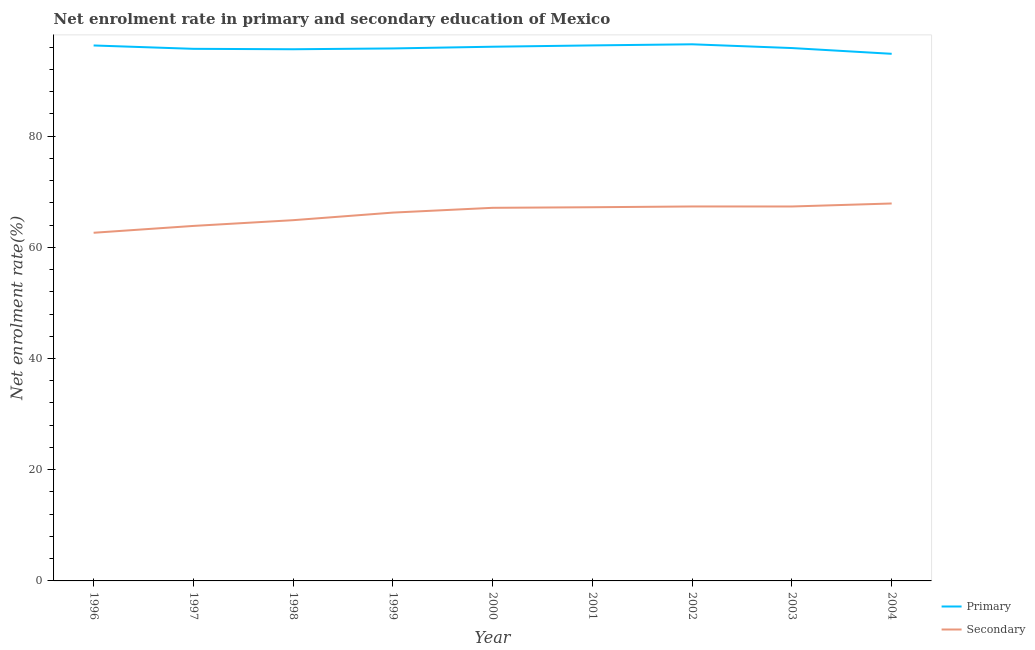How many different coloured lines are there?
Your answer should be compact. 2. Does the line corresponding to enrollment rate in primary education intersect with the line corresponding to enrollment rate in secondary education?
Ensure brevity in your answer.  No. Is the number of lines equal to the number of legend labels?
Provide a short and direct response. Yes. What is the enrollment rate in primary education in 1999?
Your response must be concise. 95.76. Across all years, what is the maximum enrollment rate in primary education?
Your response must be concise. 96.51. Across all years, what is the minimum enrollment rate in primary education?
Your answer should be very brief. 94.8. In which year was the enrollment rate in primary education maximum?
Make the answer very short. 2002. In which year was the enrollment rate in secondary education minimum?
Provide a succinct answer. 1996. What is the total enrollment rate in secondary education in the graph?
Your answer should be very brief. 594.43. What is the difference between the enrollment rate in primary education in 1997 and that in 2003?
Offer a terse response. -0.14. What is the difference between the enrollment rate in primary education in 1999 and the enrollment rate in secondary education in 2000?
Keep it short and to the point. 28.66. What is the average enrollment rate in primary education per year?
Provide a succinct answer. 95.87. In the year 1999, what is the difference between the enrollment rate in secondary education and enrollment rate in primary education?
Give a very brief answer. -29.52. In how many years, is the enrollment rate in secondary education greater than 56 %?
Provide a succinct answer. 9. What is the ratio of the enrollment rate in secondary education in 1997 to that in 2002?
Offer a terse response. 0.95. Is the enrollment rate in secondary education in 2003 less than that in 2004?
Provide a short and direct response. Yes. Is the difference between the enrollment rate in primary education in 1996 and 1999 greater than the difference between the enrollment rate in secondary education in 1996 and 1999?
Offer a very short reply. Yes. What is the difference between the highest and the second highest enrollment rate in primary education?
Make the answer very short. 0.2. What is the difference between the highest and the lowest enrollment rate in secondary education?
Give a very brief answer. 5.26. Is the enrollment rate in secondary education strictly greater than the enrollment rate in primary education over the years?
Provide a short and direct response. No. Is the enrollment rate in primary education strictly less than the enrollment rate in secondary education over the years?
Provide a short and direct response. No. How many years are there in the graph?
Offer a very short reply. 9. What is the difference between two consecutive major ticks on the Y-axis?
Provide a succinct answer. 20. Are the values on the major ticks of Y-axis written in scientific E-notation?
Make the answer very short. No. Where does the legend appear in the graph?
Your response must be concise. Bottom right. How are the legend labels stacked?
Provide a succinct answer. Vertical. What is the title of the graph?
Give a very brief answer. Net enrolment rate in primary and secondary education of Mexico. Does "Female entrants" appear as one of the legend labels in the graph?
Provide a short and direct response. No. What is the label or title of the X-axis?
Give a very brief answer. Year. What is the label or title of the Y-axis?
Provide a short and direct response. Net enrolment rate(%). What is the Net enrolment rate(%) of Primary in 1996?
Provide a short and direct response. 96.3. What is the Net enrolment rate(%) in Secondary in 1996?
Your answer should be compact. 62.61. What is the Net enrolment rate(%) of Primary in 1997?
Offer a very short reply. 95.69. What is the Net enrolment rate(%) in Secondary in 1997?
Ensure brevity in your answer.  63.84. What is the Net enrolment rate(%) of Primary in 1998?
Make the answer very short. 95.62. What is the Net enrolment rate(%) in Secondary in 1998?
Provide a succinct answer. 64.88. What is the Net enrolment rate(%) in Primary in 1999?
Provide a succinct answer. 95.76. What is the Net enrolment rate(%) in Secondary in 1999?
Your answer should be compact. 66.24. What is the Net enrolment rate(%) of Primary in 2000?
Give a very brief answer. 96.07. What is the Net enrolment rate(%) in Secondary in 2000?
Keep it short and to the point. 67.1. What is the Net enrolment rate(%) in Primary in 2001?
Your response must be concise. 96.31. What is the Net enrolment rate(%) in Secondary in 2001?
Keep it short and to the point. 67.2. What is the Net enrolment rate(%) in Primary in 2002?
Provide a succinct answer. 96.51. What is the Net enrolment rate(%) of Secondary in 2002?
Your answer should be very brief. 67.34. What is the Net enrolment rate(%) of Primary in 2003?
Ensure brevity in your answer.  95.83. What is the Net enrolment rate(%) of Secondary in 2003?
Offer a very short reply. 67.34. What is the Net enrolment rate(%) of Primary in 2004?
Provide a short and direct response. 94.8. What is the Net enrolment rate(%) in Secondary in 2004?
Provide a succinct answer. 67.88. Across all years, what is the maximum Net enrolment rate(%) of Primary?
Your response must be concise. 96.51. Across all years, what is the maximum Net enrolment rate(%) of Secondary?
Give a very brief answer. 67.88. Across all years, what is the minimum Net enrolment rate(%) of Primary?
Keep it short and to the point. 94.8. Across all years, what is the minimum Net enrolment rate(%) in Secondary?
Your answer should be compact. 62.61. What is the total Net enrolment rate(%) in Primary in the graph?
Offer a very short reply. 862.87. What is the total Net enrolment rate(%) in Secondary in the graph?
Provide a succinct answer. 594.43. What is the difference between the Net enrolment rate(%) of Primary in 1996 and that in 1997?
Offer a terse response. 0.6. What is the difference between the Net enrolment rate(%) of Secondary in 1996 and that in 1997?
Provide a short and direct response. -1.23. What is the difference between the Net enrolment rate(%) in Primary in 1996 and that in 1998?
Provide a short and direct response. 0.68. What is the difference between the Net enrolment rate(%) in Secondary in 1996 and that in 1998?
Your response must be concise. -2.26. What is the difference between the Net enrolment rate(%) of Primary in 1996 and that in 1999?
Your response must be concise. 0.53. What is the difference between the Net enrolment rate(%) of Secondary in 1996 and that in 1999?
Your response must be concise. -3.63. What is the difference between the Net enrolment rate(%) of Primary in 1996 and that in 2000?
Provide a short and direct response. 0.23. What is the difference between the Net enrolment rate(%) of Secondary in 1996 and that in 2000?
Make the answer very short. -4.49. What is the difference between the Net enrolment rate(%) in Primary in 1996 and that in 2001?
Give a very brief answer. -0.01. What is the difference between the Net enrolment rate(%) in Secondary in 1996 and that in 2001?
Your answer should be very brief. -4.59. What is the difference between the Net enrolment rate(%) in Primary in 1996 and that in 2002?
Provide a short and direct response. -0.21. What is the difference between the Net enrolment rate(%) in Secondary in 1996 and that in 2002?
Your answer should be very brief. -4.73. What is the difference between the Net enrolment rate(%) in Primary in 1996 and that in 2003?
Provide a short and direct response. 0.46. What is the difference between the Net enrolment rate(%) of Secondary in 1996 and that in 2003?
Your answer should be very brief. -4.73. What is the difference between the Net enrolment rate(%) in Primary in 1996 and that in 2004?
Offer a very short reply. 1.5. What is the difference between the Net enrolment rate(%) in Secondary in 1996 and that in 2004?
Make the answer very short. -5.26. What is the difference between the Net enrolment rate(%) of Primary in 1997 and that in 1998?
Your answer should be compact. 0.08. What is the difference between the Net enrolment rate(%) in Secondary in 1997 and that in 1998?
Offer a terse response. -1.03. What is the difference between the Net enrolment rate(%) of Primary in 1997 and that in 1999?
Provide a short and direct response. -0.07. What is the difference between the Net enrolment rate(%) in Secondary in 1997 and that in 1999?
Offer a very short reply. -2.4. What is the difference between the Net enrolment rate(%) of Primary in 1997 and that in 2000?
Your answer should be compact. -0.38. What is the difference between the Net enrolment rate(%) in Secondary in 1997 and that in 2000?
Your answer should be very brief. -3.26. What is the difference between the Net enrolment rate(%) of Primary in 1997 and that in 2001?
Your answer should be compact. -0.62. What is the difference between the Net enrolment rate(%) of Secondary in 1997 and that in 2001?
Offer a very short reply. -3.36. What is the difference between the Net enrolment rate(%) of Primary in 1997 and that in 2002?
Your answer should be very brief. -0.81. What is the difference between the Net enrolment rate(%) of Secondary in 1997 and that in 2002?
Make the answer very short. -3.5. What is the difference between the Net enrolment rate(%) of Primary in 1997 and that in 2003?
Give a very brief answer. -0.14. What is the difference between the Net enrolment rate(%) in Secondary in 1997 and that in 2003?
Your answer should be very brief. -3.5. What is the difference between the Net enrolment rate(%) of Primary in 1997 and that in 2004?
Provide a succinct answer. 0.9. What is the difference between the Net enrolment rate(%) in Secondary in 1997 and that in 2004?
Keep it short and to the point. -4.04. What is the difference between the Net enrolment rate(%) of Primary in 1998 and that in 1999?
Make the answer very short. -0.15. What is the difference between the Net enrolment rate(%) of Secondary in 1998 and that in 1999?
Make the answer very short. -1.36. What is the difference between the Net enrolment rate(%) of Primary in 1998 and that in 2000?
Ensure brevity in your answer.  -0.45. What is the difference between the Net enrolment rate(%) of Secondary in 1998 and that in 2000?
Your answer should be compact. -2.22. What is the difference between the Net enrolment rate(%) in Primary in 1998 and that in 2001?
Give a very brief answer. -0.69. What is the difference between the Net enrolment rate(%) in Secondary in 1998 and that in 2001?
Your answer should be very brief. -2.33. What is the difference between the Net enrolment rate(%) of Primary in 1998 and that in 2002?
Your answer should be very brief. -0.89. What is the difference between the Net enrolment rate(%) in Secondary in 1998 and that in 2002?
Keep it short and to the point. -2.47. What is the difference between the Net enrolment rate(%) of Primary in 1998 and that in 2003?
Ensure brevity in your answer.  -0.21. What is the difference between the Net enrolment rate(%) in Secondary in 1998 and that in 2003?
Ensure brevity in your answer.  -2.46. What is the difference between the Net enrolment rate(%) in Primary in 1998 and that in 2004?
Provide a succinct answer. 0.82. What is the difference between the Net enrolment rate(%) of Secondary in 1998 and that in 2004?
Your answer should be compact. -3. What is the difference between the Net enrolment rate(%) of Primary in 1999 and that in 2000?
Your response must be concise. -0.31. What is the difference between the Net enrolment rate(%) of Secondary in 1999 and that in 2000?
Your answer should be very brief. -0.86. What is the difference between the Net enrolment rate(%) in Primary in 1999 and that in 2001?
Give a very brief answer. -0.55. What is the difference between the Net enrolment rate(%) of Secondary in 1999 and that in 2001?
Ensure brevity in your answer.  -0.96. What is the difference between the Net enrolment rate(%) in Primary in 1999 and that in 2002?
Your response must be concise. -0.74. What is the difference between the Net enrolment rate(%) of Secondary in 1999 and that in 2002?
Offer a very short reply. -1.1. What is the difference between the Net enrolment rate(%) in Primary in 1999 and that in 2003?
Offer a terse response. -0.07. What is the difference between the Net enrolment rate(%) in Secondary in 1999 and that in 2003?
Keep it short and to the point. -1.1. What is the difference between the Net enrolment rate(%) of Secondary in 1999 and that in 2004?
Provide a short and direct response. -1.64. What is the difference between the Net enrolment rate(%) of Primary in 2000 and that in 2001?
Offer a terse response. -0.24. What is the difference between the Net enrolment rate(%) of Secondary in 2000 and that in 2001?
Provide a succinct answer. -0.1. What is the difference between the Net enrolment rate(%) of Primary in 2000 and that in 2002?
Provide a succinct answer. -0.44. What is the difference between the Net enrolment rate(%) of Secondary in 2000 and that in 2002?
Ensure brevity in your answer.  -0.24. What is the difference between the Net enrolment rate(%) in Primary in 2000 and that in 2003?
Provide a succinct answer. 0.24. What is the difference between the Net enrolment rate(%) of Secondary in 2000 and that in 2003?
Keep it short and to the point. -0.24. What is the difference between the Net enrolment rate(%) of Primary in 2000 and that in 2004?
Keep it short and to the point. 1.27. What is the difference between the Net enrolment rate(%) in Secondary in 2000 and that in 2004?
Provide a short and direct response. -0.78. What is the difference between the Net enrolment rate(%) in Primary in 2001 and that in 2002?
Provide a succinct answer. -0.2. What is the difference between the Net enrolment rate(%) in Secondary in 2001 and that in 2002?
Offer a very short reply. -0.14. What is the difference between the Net enrolment rate(%) of Primary in 2001 and that in 2003?
Give a very brief answer. 0.48. What is the difference between the Net enrolment rate(%) in Secondary in 2001 and that in 2003?
Your answer should be compact. -0.14. What is the difference between the Net enrolment rate(%) in Primary in 2001 and that in 2004?
Provide a succinct answer. 1.51. What is the difference between the Net enrolment rate(%) of Secondary in 2001 and that in 2004?
Ensure brevity in your answer.  -0.67. What is the difference between the Net enrolment rate(%) in Primary in 2002 and that in 2003?
Your answer should be very brief. 0.68. What is the difference between the Net enrolment rate(%) of Secondary in 2002 and that in 2003?
Make the answer very short. 0. What is the difference between the Net enrolment rate(%) of Primary in 2002 and that in 2004?
Keep it short and to the point. 1.71. What is the difference between the Net enrolment rate(%) of Secondary in 2002 and that in 2004?
Provide a short and direct response. -0.54. What is the difference between the Net enrolment rate(%) of Primary in 2003 and that in 2004?
Provide a succinct answer. 1.03. What is the difference between the Net enrolment rate(%) in Secondary in 2003 and that in 2004?
Provide a succinct answer. -0.54. What is the difference between the Net enrolment rate(%) in Primary in 1996 and the Net enrolment rate(%) in Secondary in 1997?
Make the answer very short. 32.45. What is the difference between the Net enrolment rate(%) of Primary in 1996 and the Net enrolment rate(%) of Secondary in 1998?
Offer a terse response. 31.42. What is the difference between the Net enrolment rate(%) of Primary in 1996 and the Net enrolment rate(%) of Secondary in 1999?
Offer a terse response. 30.06. What is the difference between the Net enrolment rate(%) of Primary in 1996 and the Net enrolment rate(%) of Secondary in 2000?
Your response must be concise. 29.2. What is the difference between the Net enrolment rate(%) of Primary in 1996 and the Net enrolment rate(%) of Secondary in 2001?
Your response must be concise. 29.09. What is the difference between the Net enrolment rate(%) of Primary in 1996 and the Net enrolment rate(%) of Secondary in 2002?
Your answer should be very brief. 28.95. What is the difference between the Net enrolment rate(%) of Primary in 1996 and the Net enrolment rate(%) of Secondary in 2003?
Provide a succinct answer. 28.96. What is the difference between the Net enrolment rate(%) in Primary in 1996 and the Net enrolment rate(%) in Secondary in 2004?
Your answer should be very brief. 28.42. What is the difference between the Net enrolment rate(%) in Primary in 1997 and the Net enrolment rate(%) in Secondary in 1998?
Provide a succinct answer. 30.82. What is the difference between the Net enrolment rate(%) of Primary in 1997 and the Net enrolment rate(%) of Secondary in 1999?
Offer a terse response. 29.45. What is the difference between the Net enrolment rate(%) in Primary in 1997 and the Net enrolment rate(%) in Secondary in 2000?
Your answer should be very brief. 28.59. What is the difference between the Net enrolment rate(%) in Primary in 1997 and the Net enrolment rate(%) in Secondary in 2001?
Your response must be concise. 28.49. What is the difference between the Net enrolment rate(%) in Primary in 1997 and the Net enrolment rate(%) in Secondary in 2002?
Your answer should be very brief. 28.35. What is the difference between the Net enrolment rate(%) in Primary in 1997 and the Net enrolment rate(%) in Secondary in 2003?
Keep it short and to the point. 28.35. What is the difference between the Net enrolment rate(%) in Primary in 1997 and the Net enrolment rate(%) in Secondary in 2004?
Your answer should be very brief. 27.82. What is the difference between the Net enrolment rate(%) of Primary in 1998 and the Net enrolment rate(%) of Secondary in 1999?
Make the answer very short. 29.38. What is the difference between the Net enrolment rate(%) of Primary in 1998 and the Net enrolment rate(%) of Secondary in 2000?
Your answer should be compact. 28.52. What is the difference between the Net enrolment rate(%) of Primary in 1998 and the Net enrolment rate(%) of Secondary in 2001?
Offer a terse response. 28.41. What is the difference between the Net enrolment rate(%) in Primary in 1998 and the Net enrolment rate(%) in Secondary in 2002?
Your response must be concise. 28.27. What is the difference between the Net enrolment rate(%) of Primary in 1998 and the Net enrolment rate(%) of Secondary in 2003?
Give a very brief answer. 28.28. What is the difference between the Net enrolment rate(%) of Primary in 1998 and the Net enrolment rate(%) of Secondary in 2004?
Provide a succinct answer. 27.74. What is the difference between the Net enrolment rate(%) in Primary in 1999 and the Net enrolment rate(%) in Secondary in 2000?
Your response must be concise. 28.66. What is the difference between the Net enrolment rate(%) in Primary in 1999 and the Net enrolment rate(%) in Secondary in 2001?
Your answer should be compact. 28.56. What is the difference between the Net enrolment rate(%) of Primary in 1999 and the Net enrolment rate(%) of Secondary in 2002?
Your answer should be very brief. 28.42. What is the difference between the Net enrolment rate(%) of Primary in 1999 and the Net enrolment rate(%) of Secondary in 2003?
Provide a succinct answer. 28.42. What is the difference between the Net enrolment rate(%) in Primary in 1999 and the Net enrolment rate(%) in Secondary in 2004?
Keep it short and to the point. 27.89. What is the difference between the Net enrolment rate(%) of Primary in 2000 and the Net enrolment rate(%) of Secondary in 2001?
Your answer should be very brief. 28.87. What is the difference between the Net enrolment rate(%) in Primary in 2000 and the Net enrolment rate(%) in Secondary in 2002?
Provide a succinct answer. 28.73. What is the difference between the Net enrolment rate(%) of Primary in 2000 and the Net enrolment rate(%) of Secondary in 2003?
Offer a very short reply. 28.73. What is the difference between the Net enrolment rate(%) of Primary in 2000 and the Net enrolment rate(%) of Secondary in 2004?
Give a very brief answer. 28.19. What is the difference between the Net enrolment rate(%) in Primary in 2001 and the Net enrolment rate(%) in Secondary in 2002?
Offer a very short reply. 28.97. What is the difference between the Net enrolment rate(%) of Primary in 2001 and the Net enrolment rate(%) of Secondary in 2003?
Make the answer very short. 28.97. What is the difference between the Net enrolment rate(%) of Primary in 2001 and the Net enrolment rate(%) of Secondary in 2004?
Offer a very short reply. 28.43. What is the difference between the Net enrolment rate(%) of Primary in 2002 and the Net enrolment rate(%) of Secondary in 2003?
Ensure brevity in your answer.  29.17. What is the difference between the Net enrolment rate(%) in Primary in 2002 and the Net enrolment rate(%) in Secondary in 2004?
Offer a terse response. 28.63. What is the difference between the Net enrolment rate(%) of Primary in 2003 and the Net enrolment rate(%) of Secondary in 2004?
Ensure brevity in your answer.  27.95. What is the average Net enrolment rate(%) of Primary per year?
Give a very brief answer. 95.88. What is the average Net enrolment rate(%) in Secondary per year?
Offer a very short reply. 66.05. In the year 1996, what is the difference between the Net enrolment rate(%) of Primary and Net enrolment rate(%) of Secondary?
Provide a succinct answer. 33.68. In the year 1997, what is the difference between the Net enrolment rate(%) of Primary and Net enrolment rate(%) of Secondary?
Your answer should be compact. 31.85. In the year 1998, what is the difference between the Net enrolment rate(%) in Primary and Net enrolment rate(%) in Secondary?
Your answer should be very brief. 30.74. In the year 1999, what is the difference between the Net enrolment rate(%) of Primary and Net enrolment rate(%) of Secondary?
Your answer should be compact. 29.52. In the year 2000, what is the difference between the Net enrolment rate(%) in Primary and Net enrolment rate(%) in Secondary?
Offer a very short reply. 28.97. In the year 2001, what is the difference between the Net enrolment rate(%) of Primary and Net enrolment rate(%) of Secondary?
Ensure brevity in your answer.  29.1. In the year 2002, what is the difference between the Net enrolment rate(%) of Primary and Net enrolment rate(%) of Secondary?
Make the answer very short. 29.16. In the year 2003, what is the difference between the Net enrolment rate(%) of Primary and Net enrolment rate(%) of Secondary?
Ensure brevity in your answer.  28.49. In the year 2004, what is the difference between the Net enrolment rate(%) of Primary and Net enrolment rate(%) of Secondary?
Your response must be concise. 26.92. What is the ratio of the Net enrolment rate(%) in Primary in 1996 to that in 1997?
Offer a terse response. 1.01. What is the ratio of the Net enrolment rate(%) of Secondary in 1996 to that in 1997?
Keep it short and to the point. 0.98. What is the ratio of the Net enrolment rate(%) of Primary in 1996 to that in 1998?
Keep it short and to the point. 1.01. What is the ratio of the Net enrolment rate(%) in Secondary in 1996 to that in 1998?
Provide a succinct answer. 0.97. What is the ratio of the Net enrolment rate(%) in Primary in 1996 to that in 1999?
Give a very brief answer. 1.01. What is the ratio of the Net enrolment rate(%) in Secondary in 1996 to that in 1999?
Provide a short and direct response. 0.95. What is the ratio of the Net enrolment rate(%) of Primary in 1996 to that in 2000?
Make the answer very short. 1. What is the ratio of the Net enrolment rate(%) of Secondary in 1996 to that in 2000?
Keep it short and to the point. 0.93. What is the ratio of the Net enrolment rate(%) in Primary in 1996 to that in 2001?
Your response must be concise. 1. What is the ratio of the Net enrolment rate(%) of Secondary in 1996 to that in 2001?
Your answer should be compact. 0.93. What is the ratio of the Net enrolment rate(%) in Secondary in 1996 to that in 2002?
Your answer should be compact. 0.93. What is the ratio of the Net enrolment rate(%) of Primary in 1996 to that in 2003?
Ensure brevity in your answer.  1. What is the ratio of the Net enrolment rate(%) of Secondary in 1996 to that in 2003?
Your answer should be very brief. 0.93. What is the ratio of the Net enrolment rate(%) of Primary in 1996 to that in 2004?
Your answer should be compact. 1.02. What is the ratio of the Net enrolment rate(%) of Secondary in 1996 to that in 2004?
Offer a terse response. 0.92. What is the ratio of the Net enrolment rate(%) in Secondary in 1997 to that in 1998?
Offer a terse response. 0.98. What is the ratio of the Net enrolment rate(%) of Primary in 1997 to that in 1999?
Make the answer very short. 1. What is the ratio of the Net enrolment rate(%) of Secondary in 1997 to that in 1999?
Your response must be concise. 0.96. What is the ratio of the Net enrolment rate(%) in Secondary in 1997 to that in 2000?
Offer a terse response. 0.95. What is the ratio of the Net enrolment rate(%) of Primary in 1997 to that in 2001?
Offer a terse response. 0.99. What is the ratio of the Net enrolment rate(%) in Primary in 1997 to that in 2002?
Make the answer very short. 0.99. What is the ratio of the Net enrolment rate(%) in Secondary in 1997 to that in 2002?
Offer a terse response. 0.95. What is the ratio of the Net enrolment rate(%) in Secondary in 1997 to that in 2003?
Offer a very short reply. 0.95. What is the ratio of the Net enrolment rate(%) of Primary in 1997 to that in 2004?
Make the answer very short. 1.01. What is the ratio of the Net enrolment rate(%) in Secondary in 1997 to that in 2004?
Ensure brevity in your answer.  0.94. What is the ratio of the Net enrolment rate(%) of Primary in 1998 to that in 1999?
Keep it short and to the point. 1. What is the ratio of the Net enrolment rate(%) of Secondary in 1998 to that in 1999?
Your answer should be very brief. 0.98. What is the ratio of the Net enrolment rate(%) of Secondary in 1998 to that in 2000?
Make the answer very short. 0.97. What is the ratio of the Net enrolment rate(%) in Primary in 1998 to that in 2001?
Your answer should be very brief. 0.99. What is the ratio of the Net enrolment rate(%) of Secondary in 1998 to that in 2001?
Ensure brevity in your answer.  0.97. What is the ratio of the Net enrolment rate(%) of Secondary in 1998 to that in 2002?
Provide a succinct answer. 0.96. What is the ratio of the Net enrolment rate(%) of Primary in 1998 to that in 2003?
Offer a terse response. 1. What is the ratio of the Net enrolment rate(%) in Secondary in 1998 to that in 2003?
Your answer should be very brief. 0.96. What is the ratio of the Net enrolment rate(%) in Primary in 1998 to that in 2004?
Your answer should be very brief. 1.01. What is the ratio of the Net enrolment rate(%) in Secondary in 1998 to that in 2004?
Offer a terse response. 0.96. What is the ratio of the Net enrolment rate(%) in Secondary in 1999 to that in 2000?
Your answer should be very brief. 0.99. What is the ratio of the Net enrolment rate(%) in Secondary in 1999 to that in 2001?
Your response must be concise. 0.99. What is the ratio of the Net enrolment rate(%) in Secondary in 1999 to that in 2002?
Your response must be concise. 0.98. What is the ratio of the Net enrolment rate(%) of Secondary in 1999 to that in 2003?
Offer a very short reply. 0.98. What is the ratio of the Net enrolment rate(%) of Primary in 1999 to that in 2004?
Provide a succinct answer. 1.01. What is the ratio of the Net enrolment rate(%) in Secondary in 1999 to that in 2004?
Offer a very short reply. 0.98. What is the ratio of the Net enrolment rate(%) of Primary in 2000 to that in 2001?
Make the answer very short. 1. What is the ratio of the Net enrolment rate(%) of Secondary in 2000 to that in 2001?
Your response must be concise. 1. What is the ratio of the Net enrolment rate(%) in Secondary in 2000 to that in 2002?
Provide a short and direct response. 1. What is the ratio of the Net enrolment rate(%) in Primary in 2000 to that in 2004?
Offer a terse response. 1.01. What is the ratio of the Net enrolment rate(%) of Primary in 2001 to that in 2002?
Your response must be concise. 1. What is the ratio of the Net enrolment rate(%) in Secondary in 2001 to that in 2002?
Provide a short and direct response. 1. What is the ratio of the Net enrolment rate(%) in Secondary in 2001 to that in 2003?
Offer a very short reply. 1. What is the ratio of the Net enrolment rate(%) of Secondary in 2002 to that in 2003?
Offer a terse response. 1. What is the ratio of the Net enrolment rate(%) of Primary in 2002 to that in 2004?
Your answer should be compact. 1.02. What is the ratio of the Net enrolment rate(%) in Primary in 2003 to that in 2004?
Your response must be concise. 1.01. What is the ratio of the Net enrolment rate(%) of Secondary in 2003 to that in 2004?
Offer a terse response. 0.99. What is the difference between the highest and the second highest Net enrolment rate(%) in Primary?
Provide a succinct answer. 0.2. What is the difference between the highest and the second highest Net enrolment rate(%) of Secondary?
Give a very brief answer. 0.54. What is the difference between the highest and the lowest Net enrolment rate(%) in Primary?
Your response must be concise. 1.71. What is the difference between the highest and the lowest Net enrolment rate(%) of Secondary?
Give a very brief answer. 5.26. 